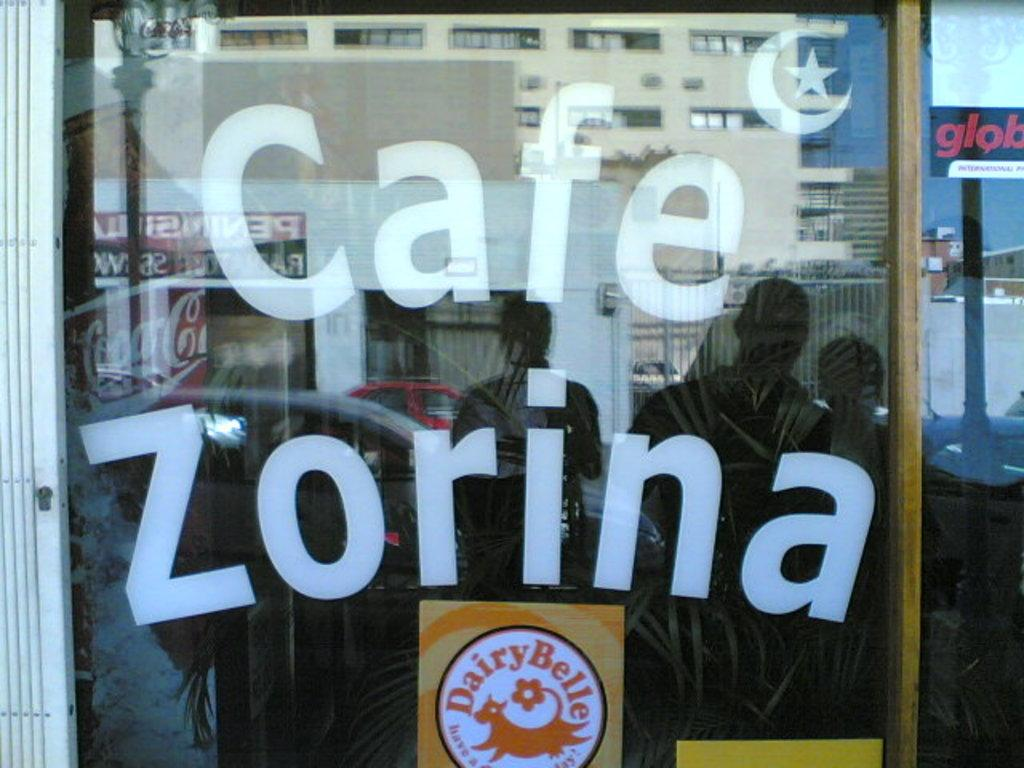What type of establishment is located in the center of the image? There is a coffee store in the center of the image. What can be seen on the coffee store? There are posters on the coffee store. Are there any people visible in the image? Yes, there are people visible in the image. What else can be seen in the image besides the coffee store and people? Cars and buildings are visible in the image. What is the purpose of the mirror in the image? The mirror is present in the image, reflecting the people, cars, and buildings. What type of stocking is being sold in the coffee store in the image? There is no mention of stockings being sold in the coffee store in the image. 